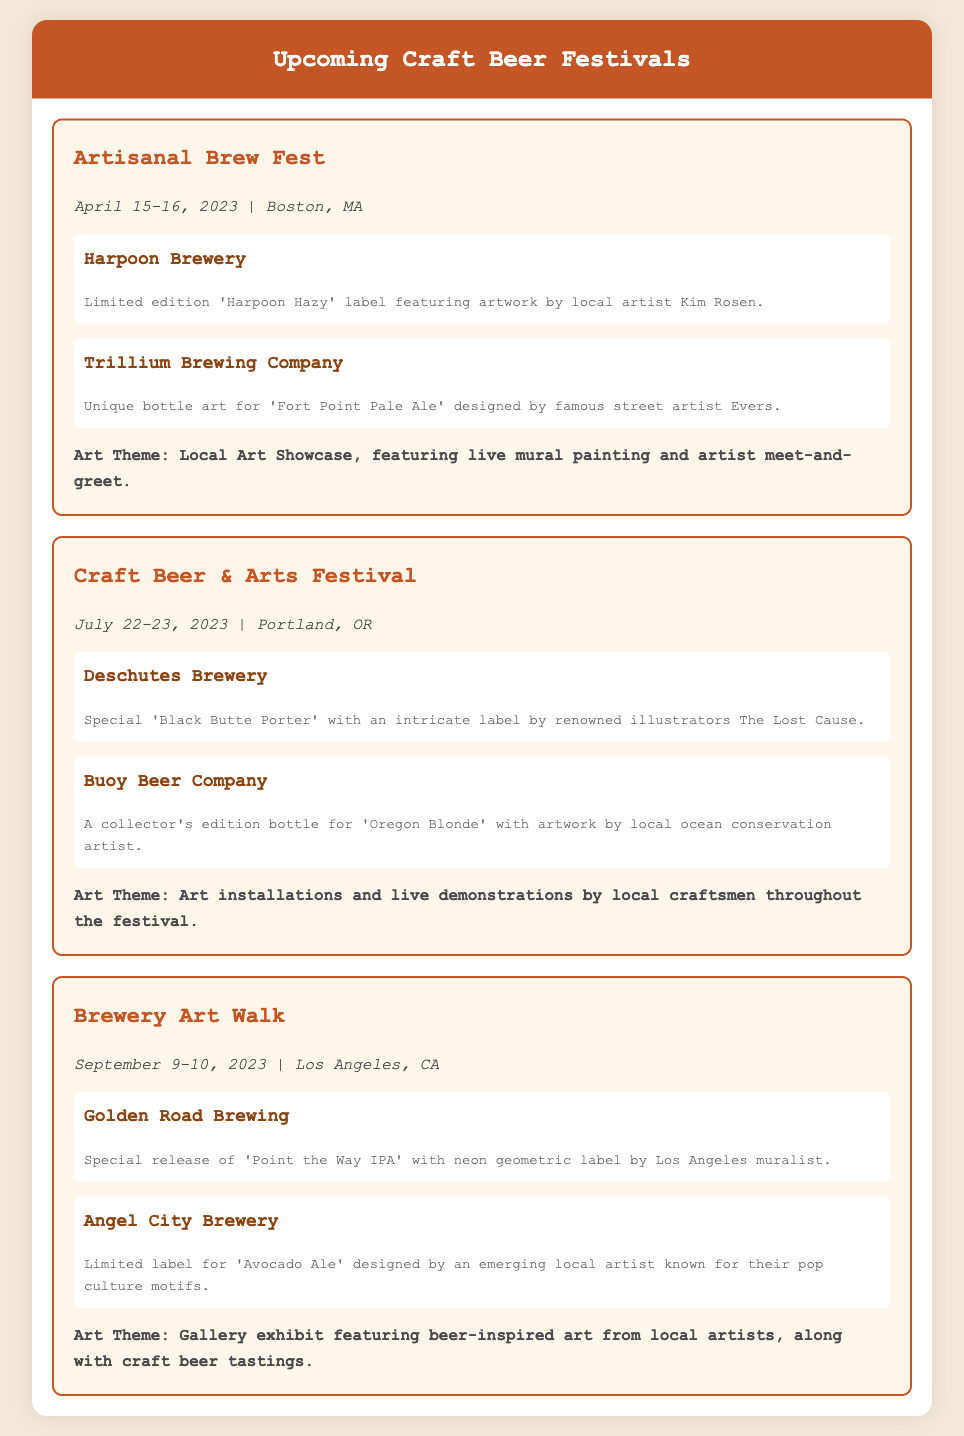What is the name of the festival in April? The document lists the festival in April as "Artisanal Brew Fest".
Answer: Artisanal Brew Fest What are the dates of the Craft Beer & Arts Festival? The Craft Beer & Arts Festival is scheduled for July 22-23, 2023.
Answer: July 22-23, 2023 Which brewery features a limited edition label by Kim Rosen? Harpoon Brewery is noted for having a limited edition label featuring artwork by Kim Rosen.
Answer: Harpoon Brewery What is the art theme for the Brewery Art Walk? The art theme for the Brewery Art Walk includes a gallery exhibit featuring beer-inspired art from local artists.
Answer: Gallery exhibit featuring beer-inspired art Who designed the label for Buoy Beer Company's 'Oregon Blonde'? The document states that the label for 'Oregon Blonde' was created by a local ocean conservation artist.
Answer: Local ocean conservation artist Which city will host the Artisanal Brew Fest? The document indicates that the Artisanal Brew Fest will be held in Boston, MA.
Answer: Boston, MA 